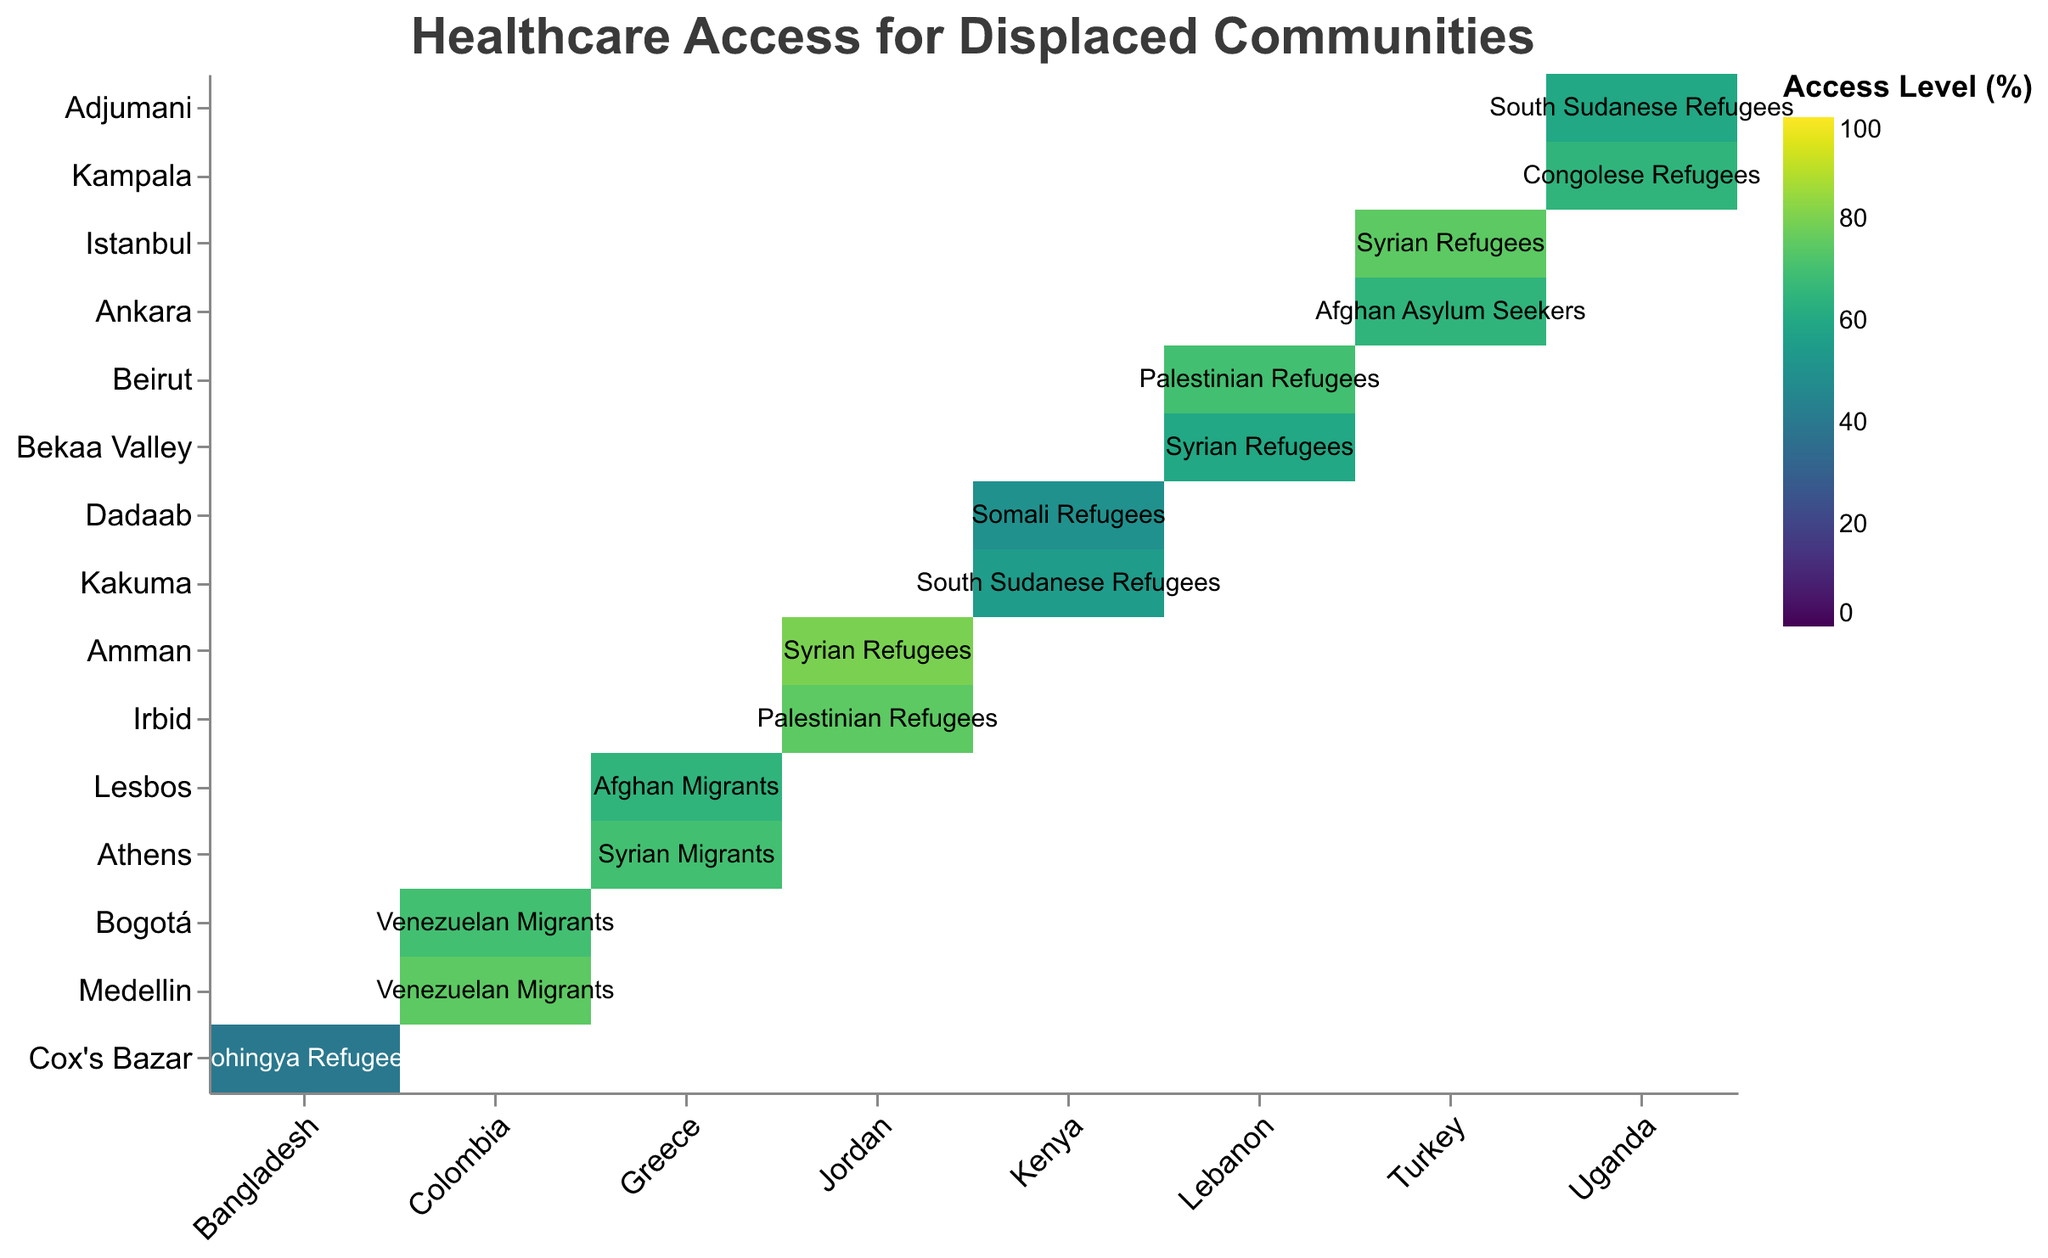What is the title of the heatmap? The title of a plot is usually displayed at the top, summarizing the information represented in the graph. In this heatmap, the title should provide an overview of what the data is about.
Answer: Healthcare Access for Displaced Communities Which country has the highest primary healthcare access for Syrian Refugees? To determine this, locate the Syrian Refugees in the regions of various countries in the heatmap, and compare their Primary Healthcare Access levels. Beirut in Lebanon shows 60%, Istanbul in Turkey shows 75%, and Amman in Jordan shows 80%. Therefore, Jordan has the highest.
Answer: Jordan What is the average primary healthcare access for displaced communities in Colombia? Locate the regions in Colombia (Bogotá and Medellin), and find the primary healthcare access values for these areas (70 and 75). The average is calculated as (70 + 75) / 2 = 72.5.
Answer: 72.5 Which region in Uganda provides higher primary healthcare access to South Sudanese Refugees? Compare the primary healthcare access between Adjumani and Kampala for South Sudanese Refugees. Adjumani has 60%, and Kampala is not for South Sudanese Refugees but for Congolese Refugees, so it's invalid.
Answer: Adjumani What is the difference in specialized healthcare access between Syrian Refugees in Amman and Istanbul? Locate Amman and Istanbul for Syrian Refugees. Compare specialized healthcare access values: Amman has 50%, Istanbul has 40%. The difference is 50 - 40 = 10.
Answer: 10 Which displaced community has the lowest access to secondary healthcare services in the heatmap? Check across all entries for each community's secondary healthcare access value. The lowest value is for Somali Refugees in Dadaab, Kenya, which is 35.
Answer: Somali Refugees in Dadaab What is the overall trend in primary healthcare access among displaced communities in Greece? Examine the Primary Healthcare Access for Afghan Migrants in Lesbos (65) and Syrian Migrants in Athens (70). The trend shows higher primary healthcare access for Syrian Migrants compared to Afghan Migrants.
Answer: Increasing Among all listed regions, which has the least primary healthcare access provided to displaced communities? Scan all the data points for the lowest primary healthcare access value. Rohingya Refugees in Cox's Bazar have the lowest primary healthcare access at 40%.
Answer: Cox's Bazar Compare the primary healthcare access between Syrian Refugees and Palestinian Refugees in Lebanon. Identify the regions for these communities: Syrian Refugees in Bekaa Valley (60) and Palestinian Refugees in Beirut (70). Palestinian Refugees in Beirut have higher access.
Answer: Palestinian Refugees in Beirut 